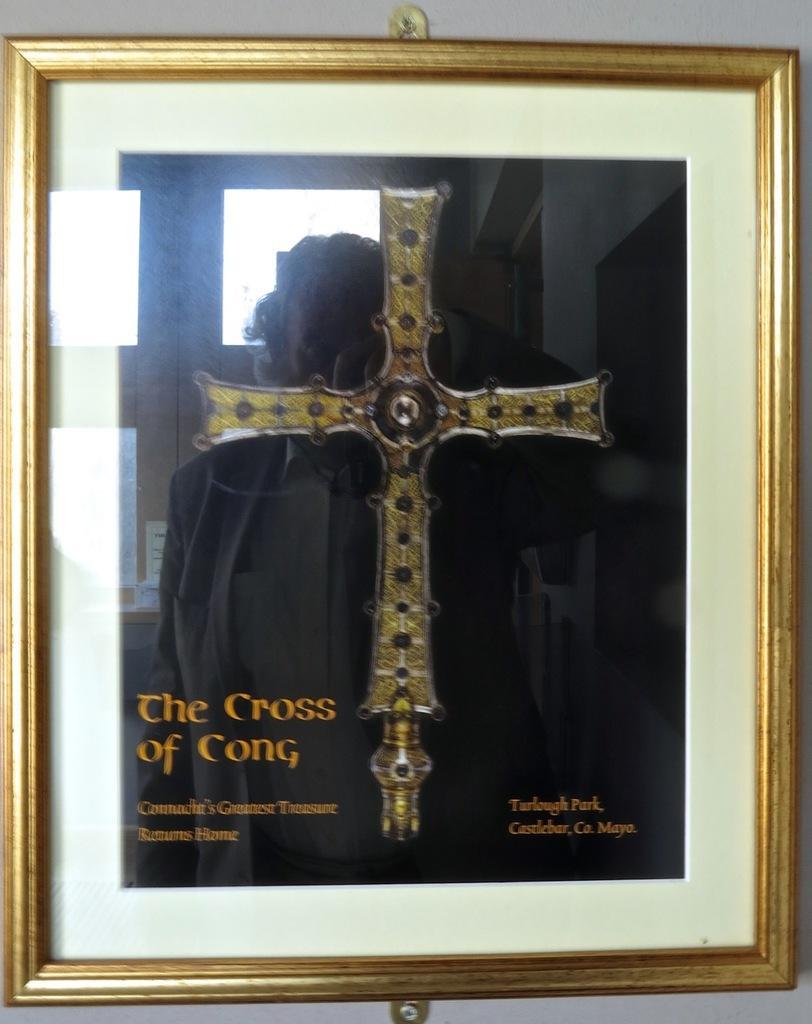How would you summarize this image in a sentence or two? In this image, we can see photo frame on the wall contains a cross and some text. 